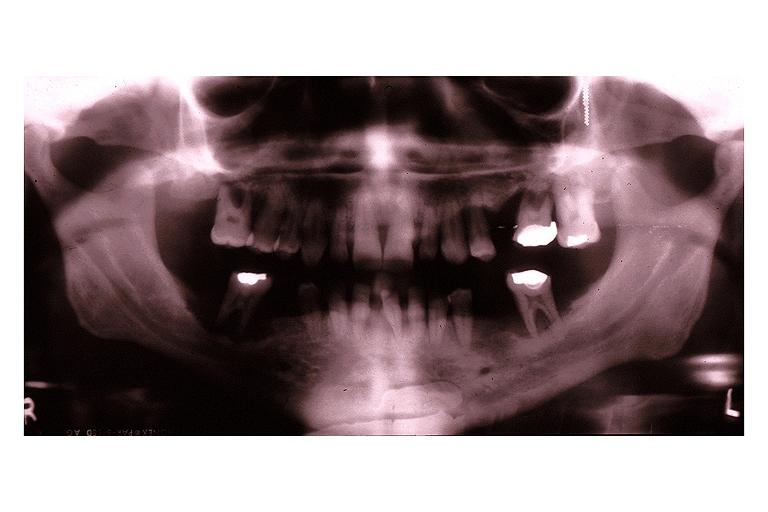s oral present?
Answer the question using a single word or phrase. Yes 